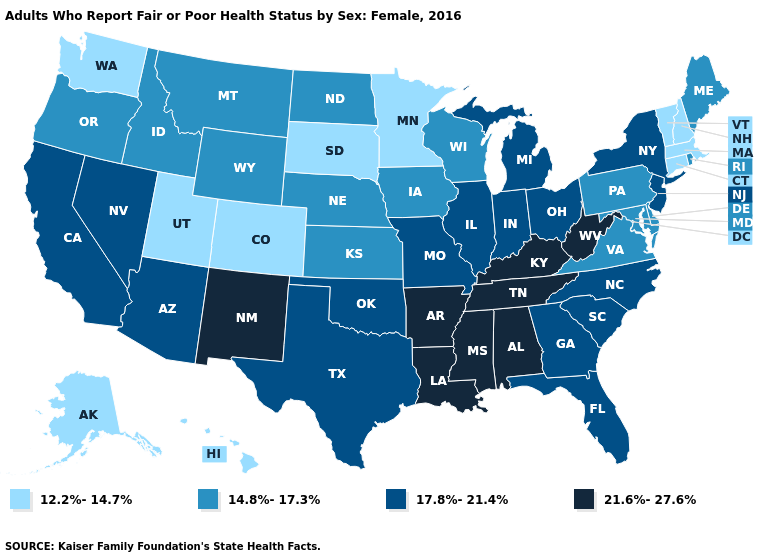Name the states that have a value in the range 17.8%-21.4%?
Be succinct. Arizona, California, Florida, Georgia, Illinois, Indiana, Michigan, Missouri, Nevada, New Jersey, New York, North Carolina, Ohio, Oklahoma, South Carolina, Texas. Name the states that have a value in the range 14.8%-17.3%?
Be succinct. Delaware, Idaho, Iowa, Kansas, Maine, Maryland, Montana, Nebraska, North Dakota, Oregon, Pennsylvania, Rhode Island, Virginia, Wisconsin, Wyoming. What is the highest value in states that border California?
Answer briefly. 17.8%-21.4%. Does the map have missing data?
Quick response, please. No. Does Kentucky have the highest value in the USA?
Answer briefly. Yes. How many symbols are there in the legend?
Write a very short answer. 4. Name the states that have a value in the range 14.8%-17.3%?
Answer briefly. Delaware, Idaho, Iowa, Kansas, Maine, Maryland, Montana, Nebraska, North Dakota, Oregon, Pennsylvania, Rhode Island, Virginia, Wisconsin, Wyoming. What is the value of New Hampshire?
Quick response, please. 12.2%-14.7%. Which states have the lowest value in the Northeast?
Give a very brief answer. Connecticut, Massachusetts, New Hampshire, Vermont. Name the states that have a value in the range 14.8%-17.3%?
Quick response, please. Delaware, Idaho, Iowa, Kansas, Maine, Maryland, Montana, Nebraska, North Dakota, Oregon, Pennsylvania, Rhode Island, Virginia, Wisconsin, Wyoming. What is the value of Colorado?
Short answer required. 12.2%-14.7%. Does the map have missing data?
Concise answer only. No. Which states have the highest value in the USA?
Be succinct. Alabama, Arkansas, Kentucky, Louisiana, Mississippi, New Mexico, Tennessee, West Virginia. Name the states that have a value in the range 17.8%-21.4%?
Short answer required. Arizona, California, Florida, Georgia, Illinois, Indiana, Michigan, Missouri, Nevada, New Jersey, New York, North Carolina, Ohio, Oklahoma, South Carolina, Texas. Name the states that have a value in the range 21.6%-27.6%?
Keep it brief. Alabama, Arkansas, Kentucky, Louisiana, Mississippi, New Mexico, Tennessee, West Virginia. 